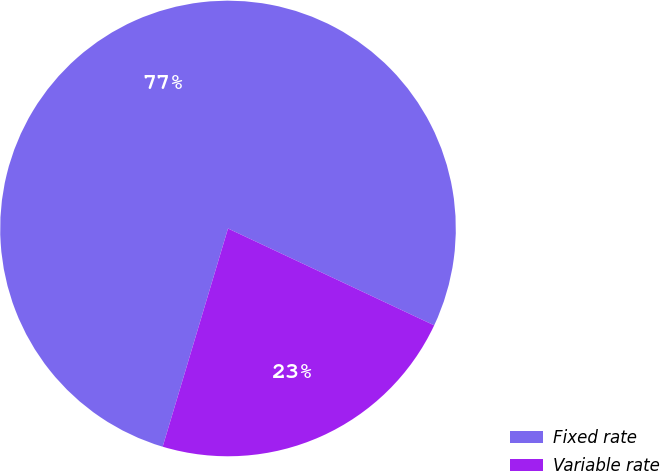<chart> <loc_0><loc_0><loc_500><loc_500><pie_chart><fcel>Fixed rate<fcel>Variable rate<nl><fcel>77.36%<fcel>22.64%<nl></chart> 